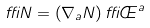Convert formula to latex. <formula><loc_0><loc_0><loc_500><loc_500>\delta N = \left ( \nabla _ { a } N \right ) \delta \phi ^ { a }</formula> 